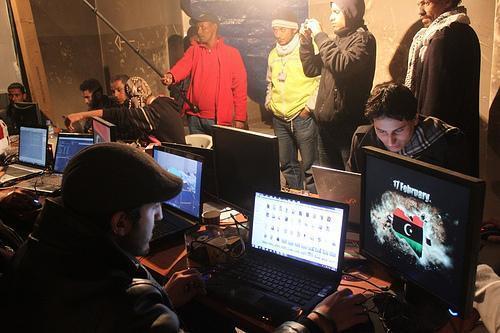How many computer screens in this picture depict a flag?
Give a very brief answer. 1. 